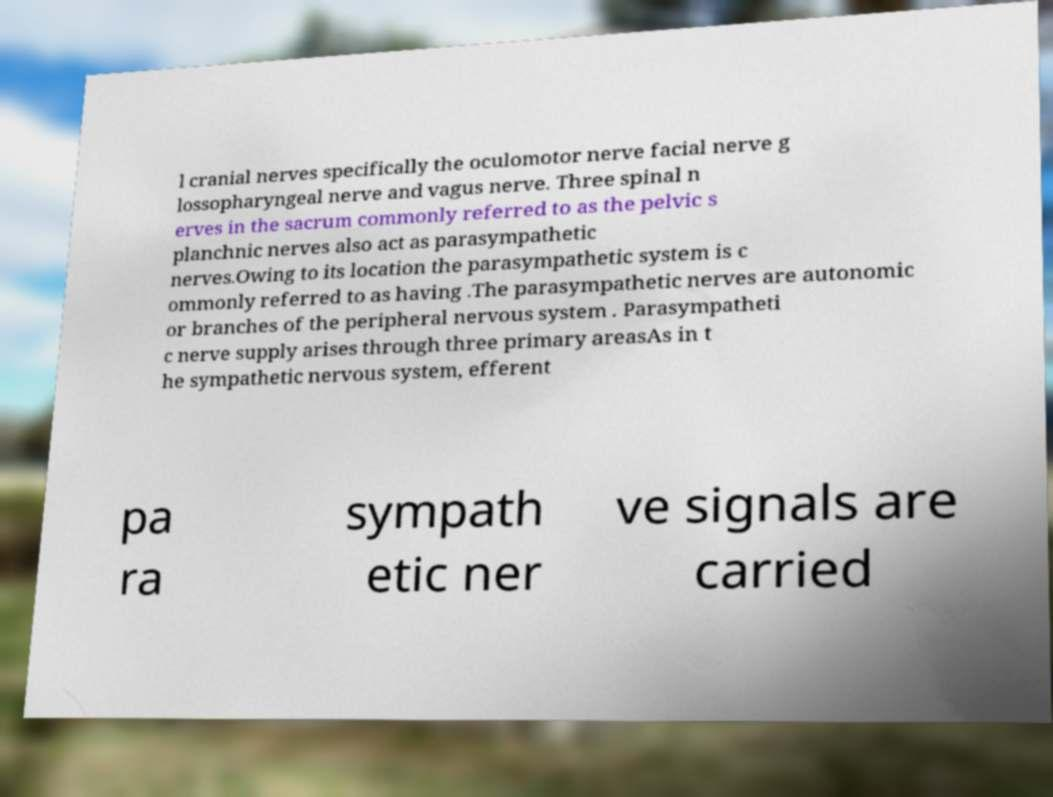Can you read and provide the text displayed in the image?This photo seems to have some interesting text. Can you extract and type it out for me? l cranial nerves specifically the oculomotor nerve facial nerve g lossopharyngeal nerve and vagus nerve. Three spinal n erves in the sacrum commonly referred to as the pelvic s planchnic nerves also act as parasympathetic nerves.Owing to its location the parasympathetic system is c ommonly referred to as having .The parasympathetic nerves are autonomic or branches of the peripheral nervous system . Parasympatheti c nerve supply arises through three primary areasAs in t he sympathetic nervous system, efferent pa ra sympath etic ner ve signals are carried 